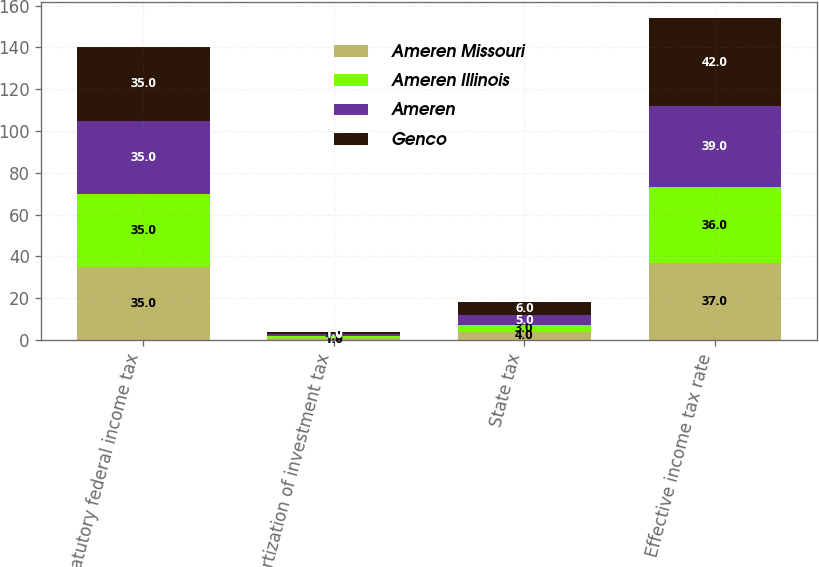Convert chart. <chart><loc_0><loc_0><loc_500><loc_500><stacked_bar_chart><ecel><fcel>Statutory federal income tax<fcel>Amortization of investment tax<fcel>State tax<fcel>Effective income tax rate<nl><fcel>Ameren Missouri<fcel>35<fcel>1<fcel>4<fcel>37<nl><fcel>Ameren Illinois<fcel>35<fcel>1<fcel>3<fcel>36<nl><fcel>Ameren<fcel>35<fcel>1<fcel>5<fcel>39<nl><fcel>Genco<fcel>35<fcel>1<fcel>6<fcel>42<nl></chart> 